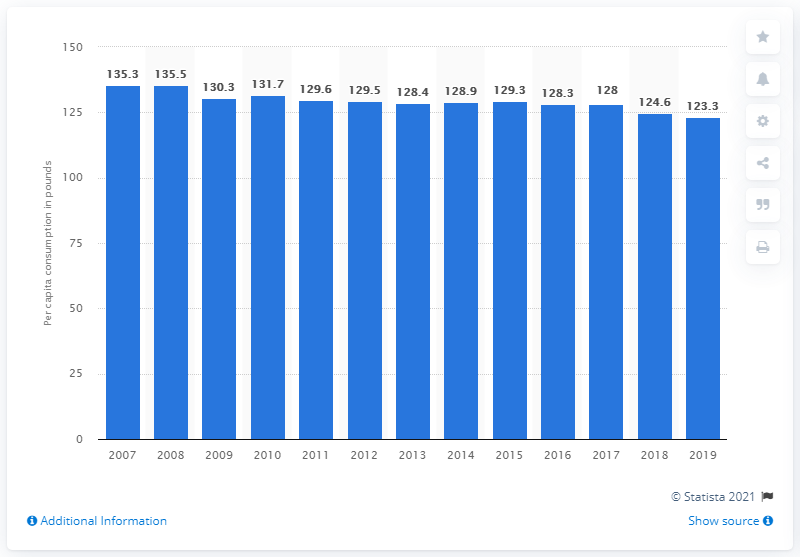Draw attention to some important aspects in this diagram. Since 2007, per-capita consumption of caloric sweeteners has been on a decline. 